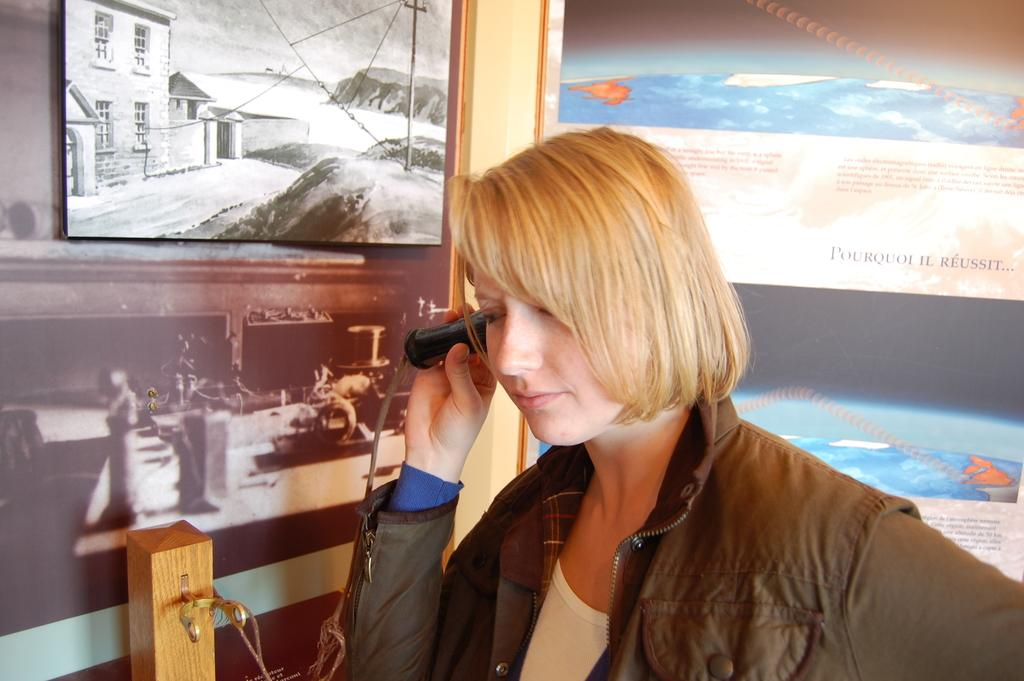Who is present in the image? There is a woman in the image. What is the woman wearing? The woman is wearing clothes. What is the woman holding in the image? The woman is holding an object. What can be seen around the woman in the image? There is a frame and a poster in the image. Can you describe the object that the woman is holding? Unfortunately, the specific object cannot be determined from the provided facts. How many dolls are sitting on the cat in the image? There is no cat or doll present in the image. 